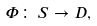<formula> <loc_0><loc_0><loc_500><loc_500>\Phi \colon \, S \to D ,</formula> 